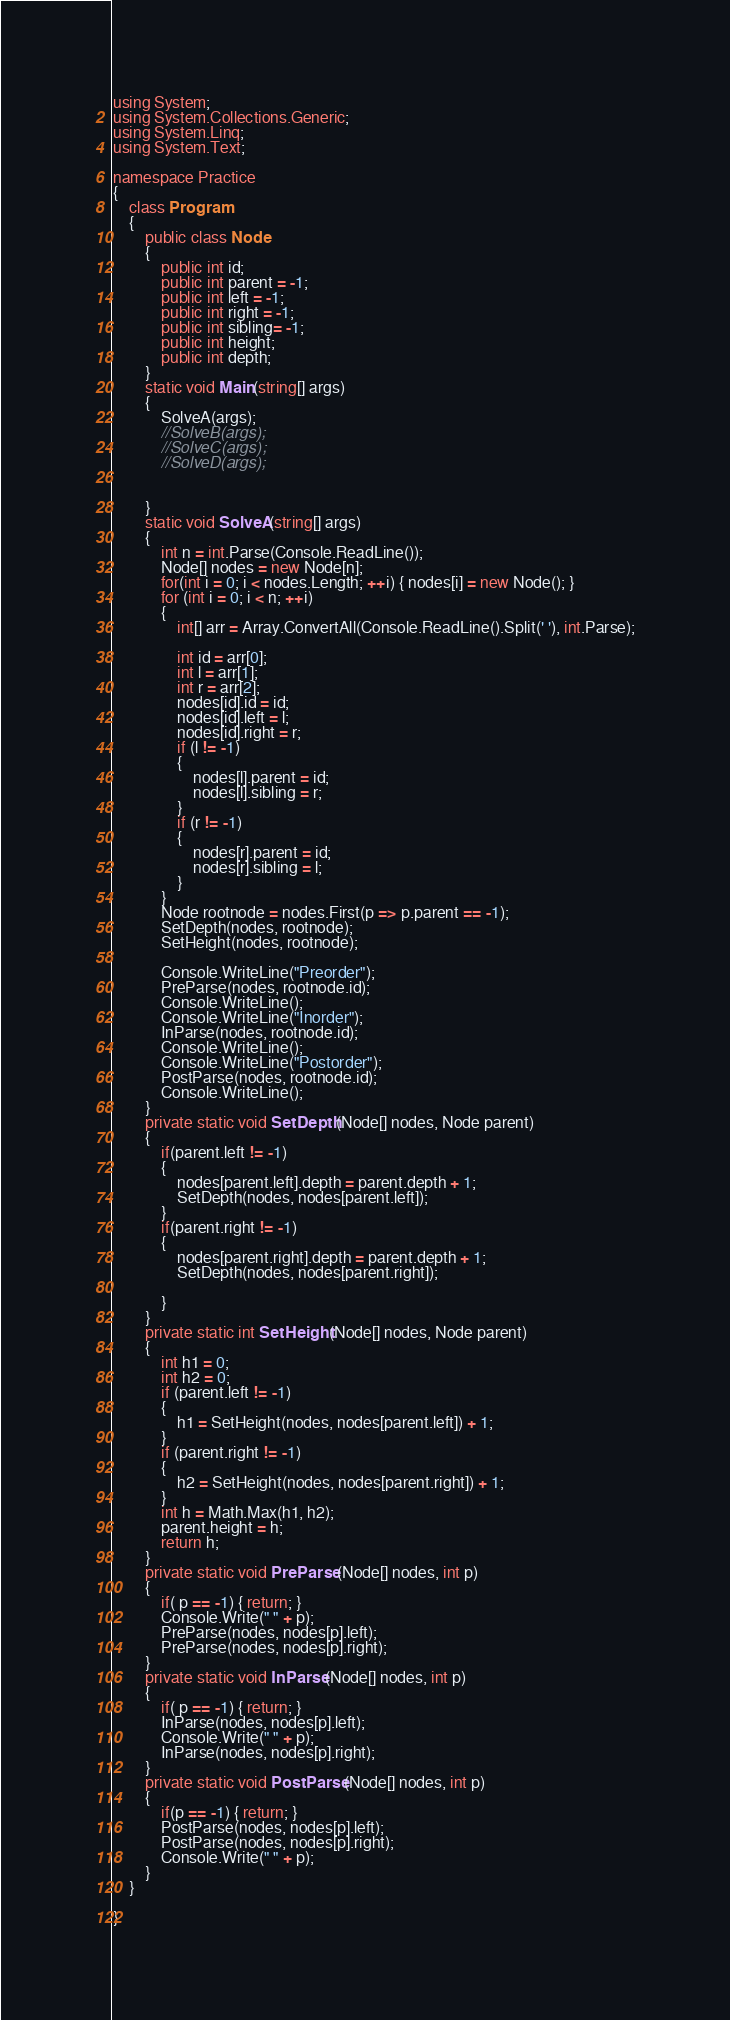Convert code to text. <code><loc_0><loc_0><loc_500><loc_500><_C#_>using System;
using System.Collections.Generic;
using System.Linq;
using System.Text;

namespace Practice
{
    class Program
    {
        public class Node
        {
            public int id;
            public int parent = -1;
            public int left = -1;
            public int right = -1;
            public int sibling= -1;
            public int height;
            public int depth;
        }
        static void Main(string[] args)
        {
            SolveA(args);
            //SolveB(args);
            //SolveC(args);
            //SolveD(args);


        }
        static void SolveA(string[] args)
        {
            int n = int.Parse(Console.ReadLine());
            Node[] nodes = new Node[n];
            for(int i = 0; i < nodes.Length; ++i) { nodes[i] = new Node(); }
            for (int i = 0; i < n; ++i)
            {
                int[] arr = Array.ConvertAll(Console.ReadLine().Split(' '), int.Parse);
               
                int id = arr[0];
                int l = arr[1];
                int r = arr[2];
                nodes[id].id = id;
                nodes[id].left = l;
                nodes[id].right = r;
                if (l != -1)
                {
                    nodes[l].parent = id;
                    nodes[l].sibling = r;
                }
                if (r != -1)
                {
                    nodes[r].parent = id;
                    nodes[r].sibling = l;
                }
            }
            Node rootnode = nodes.First(p => p.parent == -1);
            SetDepth(nodes, rootnode);
            SetHeight(nodes, rootnode);

            Console.WriteLine("Preorder");
            PreParse(nodes, rootnode.id);
            Console.WriteLine();
            Console.WriteLine("Inorder");
            InParse(nodes, rootnode.id);
            Console.WriteLine();
            Console.WriteLine("Postorder");
            PostParse(nodes, rootnode.id);
            Console.WriteLine();
        }
        private static void SetDepth(Node[] nodes, Node parent)
        {
            if(parent.left != -1)
            {
                nodes[parent.left].depth = parent.depth + 1;
                SetDepth(nodes, nodes[parent.left]);
            }
            if(parent.right != -1)
            {
                nodes[parent.right].depth = parent.depth + 1;
                SetDepth(nodes, nodes[parent.right]);

            }
        }
        private static int SetHeight(Node[] nodes, Node parent)
        {
            int h1 = 0;
            int h2 = 0;
            if (parent.left != -1)
            {
                h1 = SetHeight(nodes, nodes[parent.left]) + 1;
            }
            if (parent.right != -1)
            {
                h2 = SetHeight(nodes, nodes[parent.right]) + 1;
            }
            int h = Math.Max(h1, h2);
            parent.height = h;
            return h;
        }
        private static void PreParse(Node[] nodes, int p)
        {
            if( p == -1) { return; }
            Console.Write(" " + p);
            PreParse(nodes, nodes[p].left);
            PreParse(nodes, nodes[p].right);
        }
        private static void InParse(Node[] nodes, int p)
        {
            if( p == -1) { return; }
            InParse(nodes, nodes[p].left);
            Console.Write(" " + p);
            InParse(nodes, nodes[p].right);
        }
        private static void PostParse(Node[] nodes, int p)
        {
            if(p == -1) { return; }
            PostParse(nodes, nodes[p].left);
            PostParse(nodes, nodes[p].right);
            Console.Write(" " + p);
        }
    }

}

</code> 